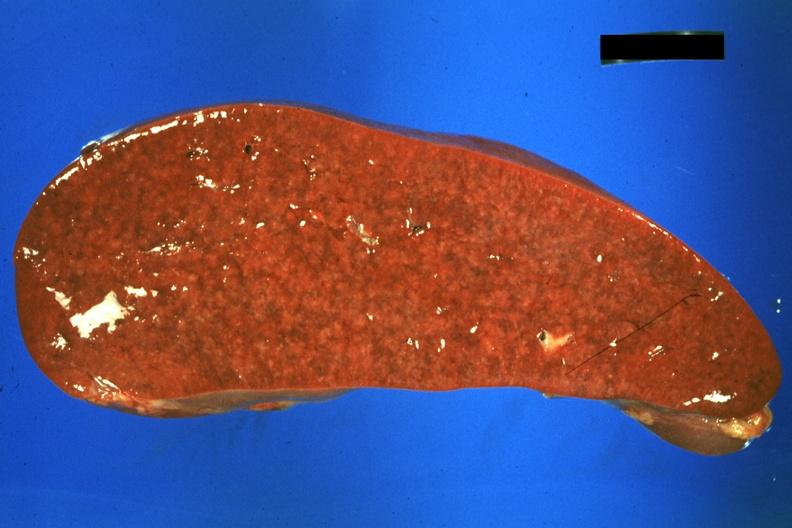what is present?
Answer the question using a single word or phrase. Hematologic 